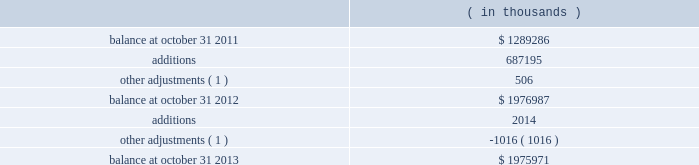Synopsys , inc .
Notes to consolidated financial statements 2014continued acquired identifiable intangible assets of $ 107.3 million , resulting in total goodwill of $ 257.6 million .
Identifiable intangible assets are being amortized over three to eight years .
Acquisition-related costs directly attributable to the business combination were $ 6.6 million for fiscal 2012 and were expensed as incurred in the consolidated statements of operations .
These costs consisted primarily of employee separation costs and professional services .
Acquisition of magma design automation , inc .
( magma ) on february 22 , 2012 , the company acquired magma , a chip design software provider , at a per- share price of $ 7.35 .
Additionally , the company assumed unvested restricted stock units ( rsus ) and stock options , collectively called 201cequity awards . 201d the aggregate purchase price was approximately $ 550.2 million .
This acquisition enables the company to more rapidly meet the needs of leading-edge semiconductor designers for more sophisticated design tools .
The company allocated the total purchase consideration of $ 550.2 million ( including $ 6.8 million related to equity awards assumed ) to the assets acquired and liabilities assumed based on their respective fair values at the acquisition date , including acquired identifiable intangible assets of $ 184.3 million , resulting in total goodwill of $ 316.3 million .
Identifiable intangible assets are being amortized over three to ten years .
Acquisition-related costs directly attributable to the business combination totaling $ 33.5 million for fiscal 2012 were expensed as incurred in the consolidated statements of operations and consist primarily of employee separation costs , contract terminations , professional services , and facilities closure costs .
Other fiscal 2012 acquisitions during fiscal 2012 , the company acquired five other companies , including emulation & verification engineering , s.a .
( eve ) , for cash and allocated the total purchase consideration of $ 213.2 million to the assets acquired and liabilities assumed based on their respective fair values , resulting in total goodwill of $ 118.1 million .
Acquired identifiable intangible assets totaling $ 73.3 million were valued using appropriate valuation methods such as income or cost methods and are being amortized over their respective useful lives ranging from one to eight years .
During fiscal 2012 , acquisition-related costs totaling $ 6.8 million were expensed as incurred in the consolidated statements of operations .
Fiscal 2011 acquisitions during fiscal 2011 , the company completed two acquisitions for cash and allocated the total purchase consideration of $ 37.4 million to the assets and liabilities acquired based on their respective fair values at the acquisition date resulting in goodwill of $ 30.6 million .
Acquired identifiable intangible assets of $ 9.3 million are being amortized over two to ten years .
Note 4 .
Goodwill and intangible assets goodwill: .

What is the identifiable intangible assets as a percent of total goodwill? 
Rationale: it is the value of intangible assets divided by the total goodwill .
Computations: (107.3 / 257.6)
Answer: 0.41654. 